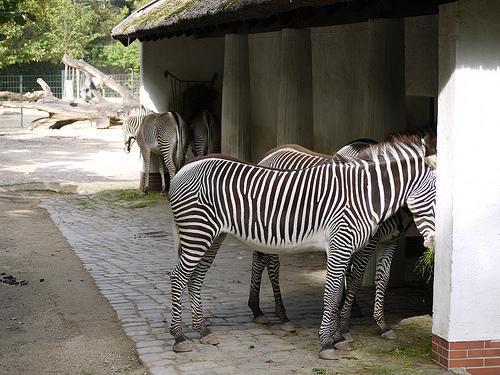How many buildings are there?
Give a very brief answer. 1. 